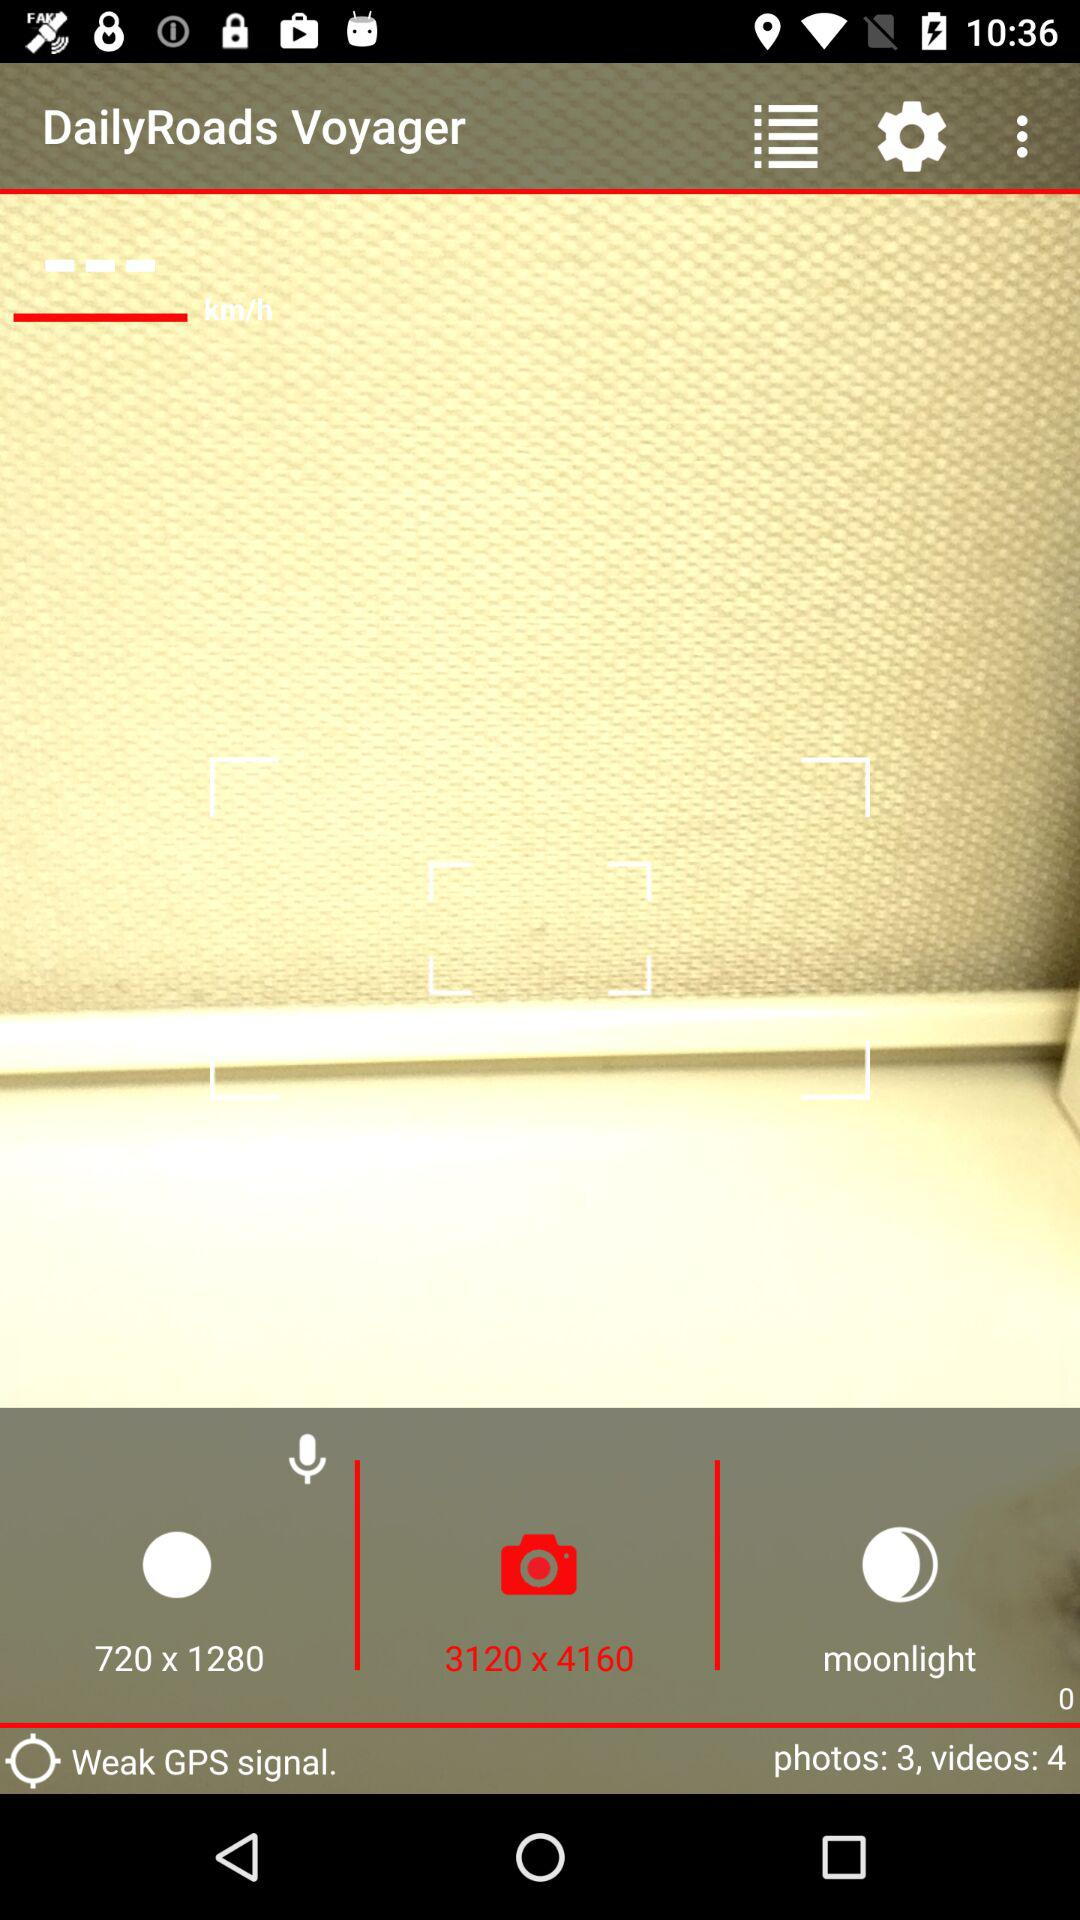How many videos are there? There are 4 videos. 